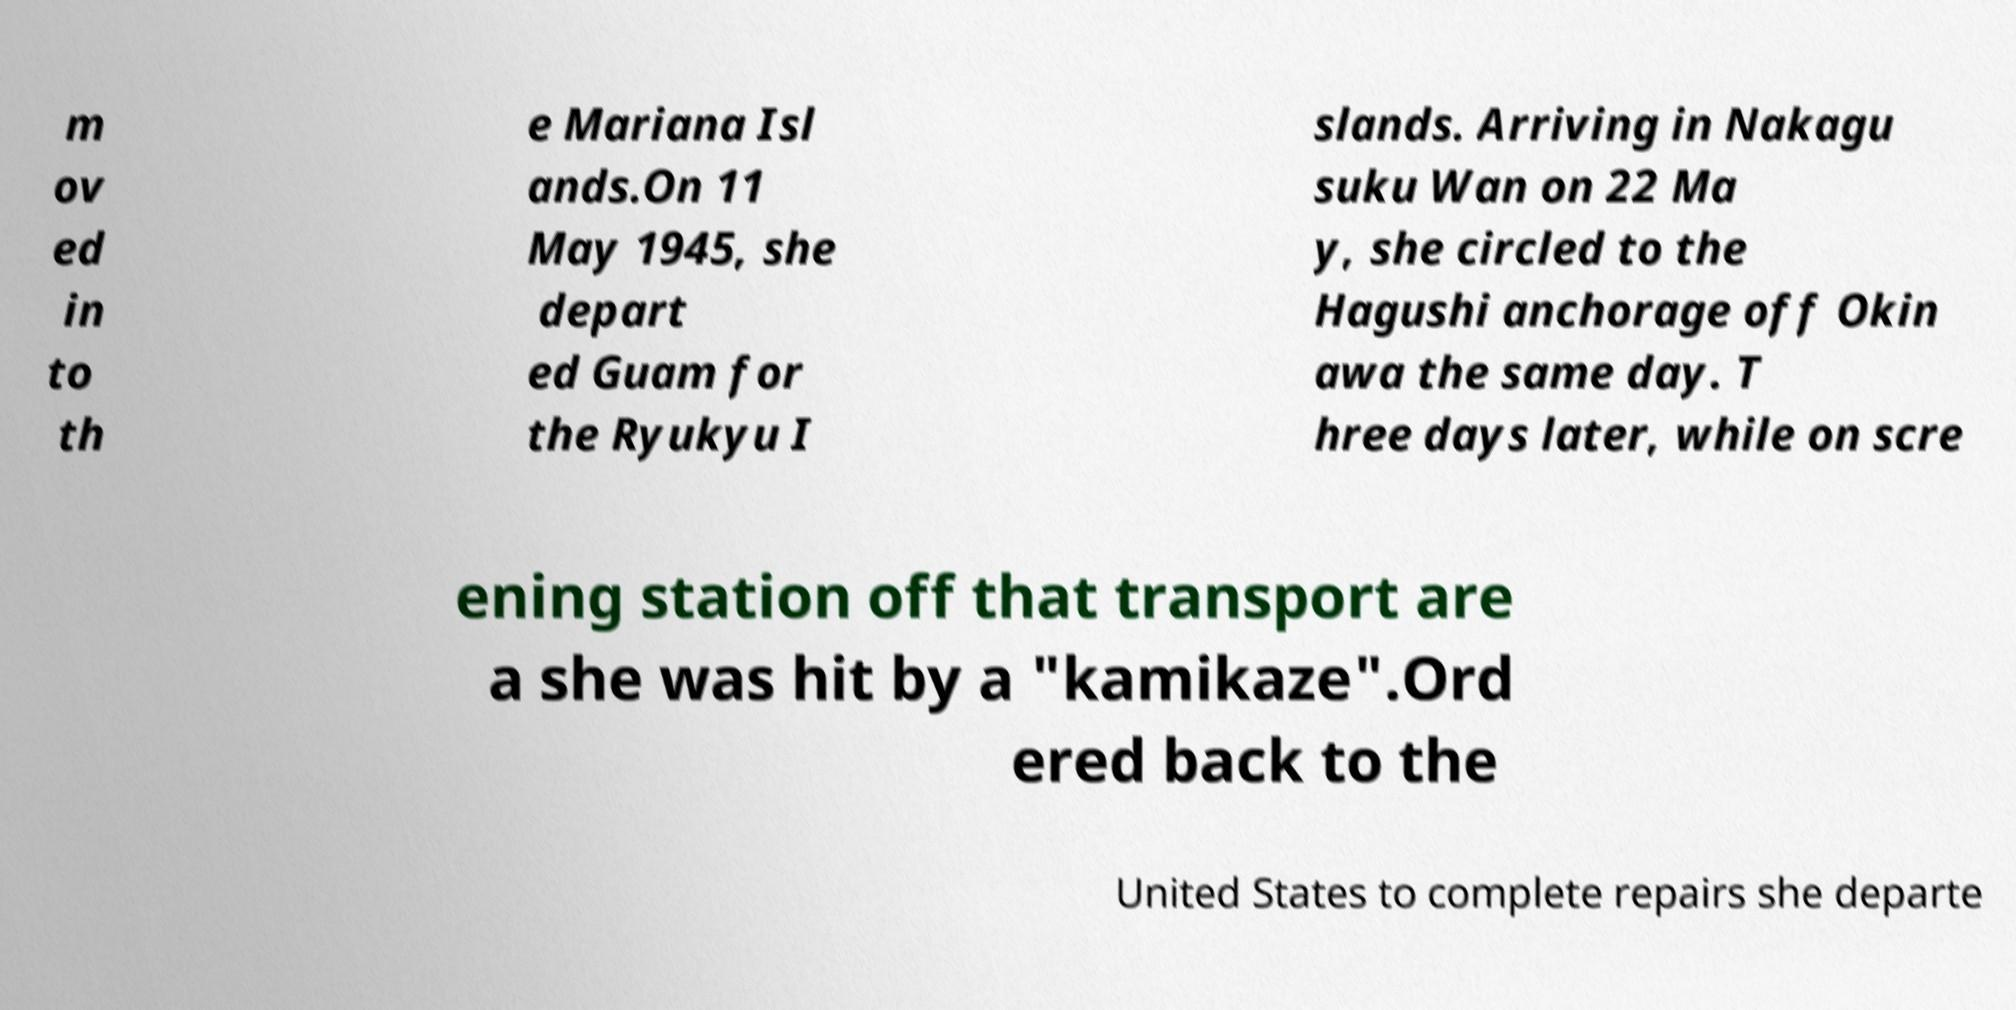Can you read and provide the text displayed in the image?This photo seems to have some interesting text. Can you extract and type it out for me? m ov ed in to th e Mariana Isl ands.On 11 May 1945, she depart ed Guam for the Ryukyu I slands. Arriving in Nakagu suku Wan on 22 Ma y, she circled to the Hagushi anchorage off Okin awa the same day. T hree days later, while on scre ening station off that transport are a she was hit by a "kamikaze".Ord ered back to the United States to complete repairs she departe 